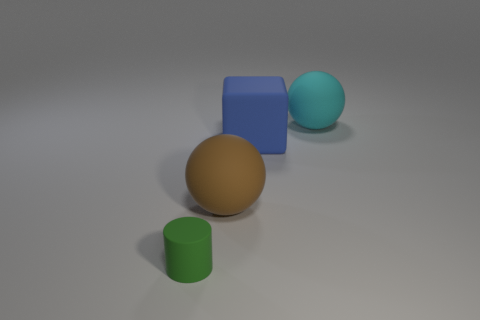Are there an equal number of green matte objects that are right of the blue thing and tiny matte cylinders that are to the left of the tiny rubber cylinder?
Offer a very short reply. Yes. Is the blue cube made of the same material as the green cylinder?
Make the answer very short. Yes. How many green objects are rubber spheres or large metallic blocks?
Keep it short and to the point. 0. How many other brown things have the same shape as the brown matte object?
Make the answer very short. 0. Are there the same number of big brown rubber balls that are on the right side of the cyan rubber ball and large purple balls?
Offer a terse response. Yes. There is a cyan matte thing that is the same size as the brown thing; what is its shape?
Provide a succinct answer. Sphere. There is a big sphere to the left of the big blue cube; is there a big rubber ball in front of it?
Keep it short and to the point. No. How many small objects are either green matte things or red metal balls?
Ensure brevity in your answer.  1. Are there any cyan spheres of the same size as the blue cube?
Offer a terse response. Yes. How many metal objects are either tiny green things or big cyan things?
Provide a succinct answer. 0. 